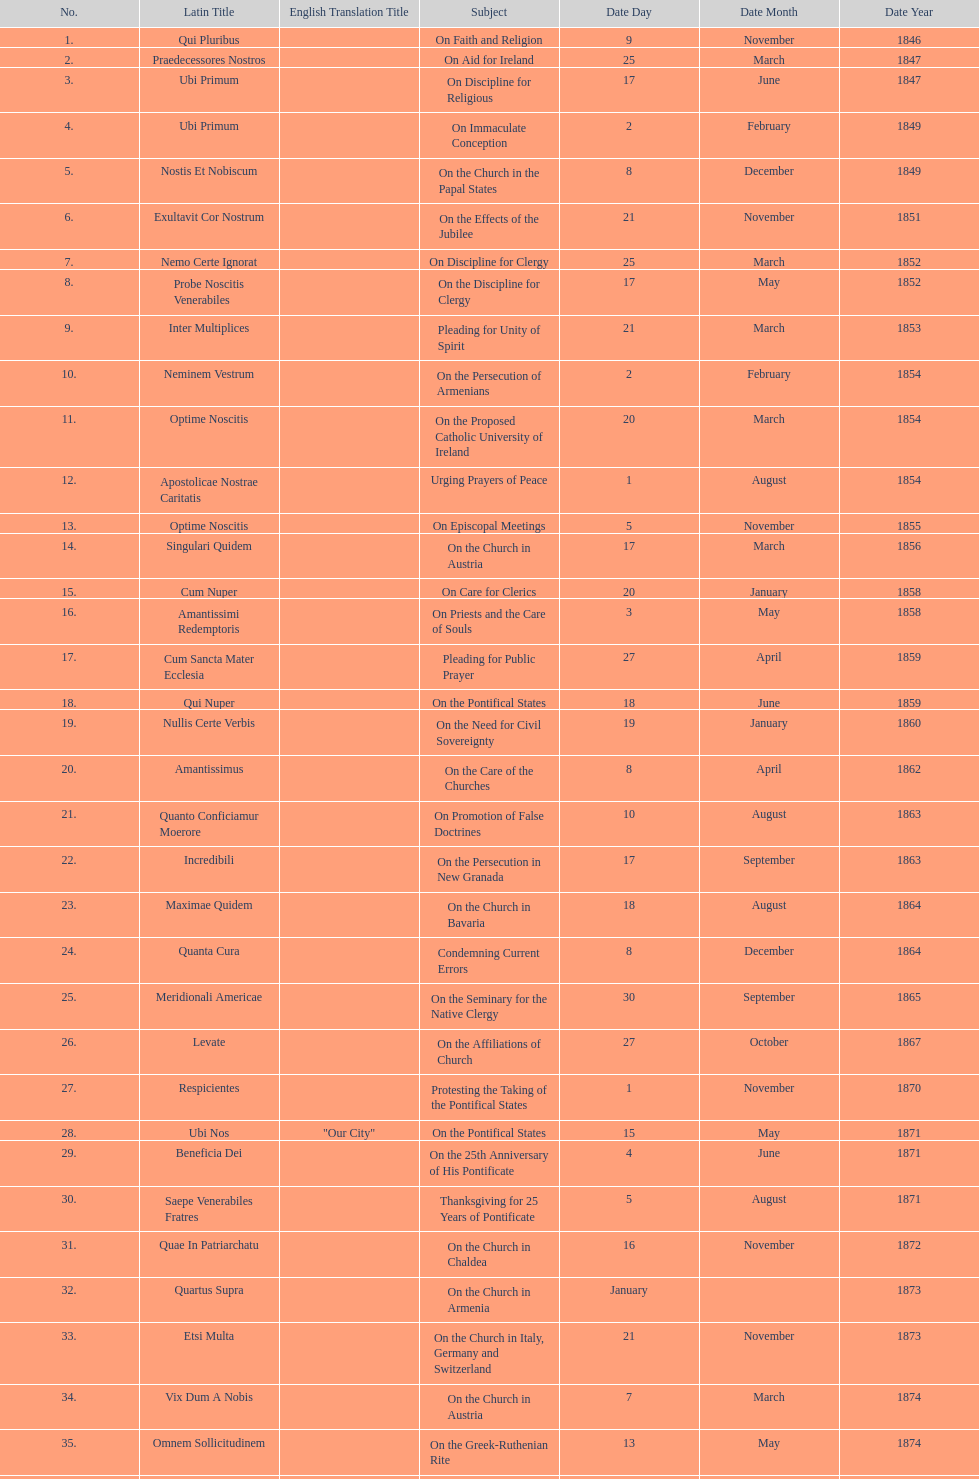In the first 10 years of his reign, how many encyclicals did pope pius ix issue? 14. 